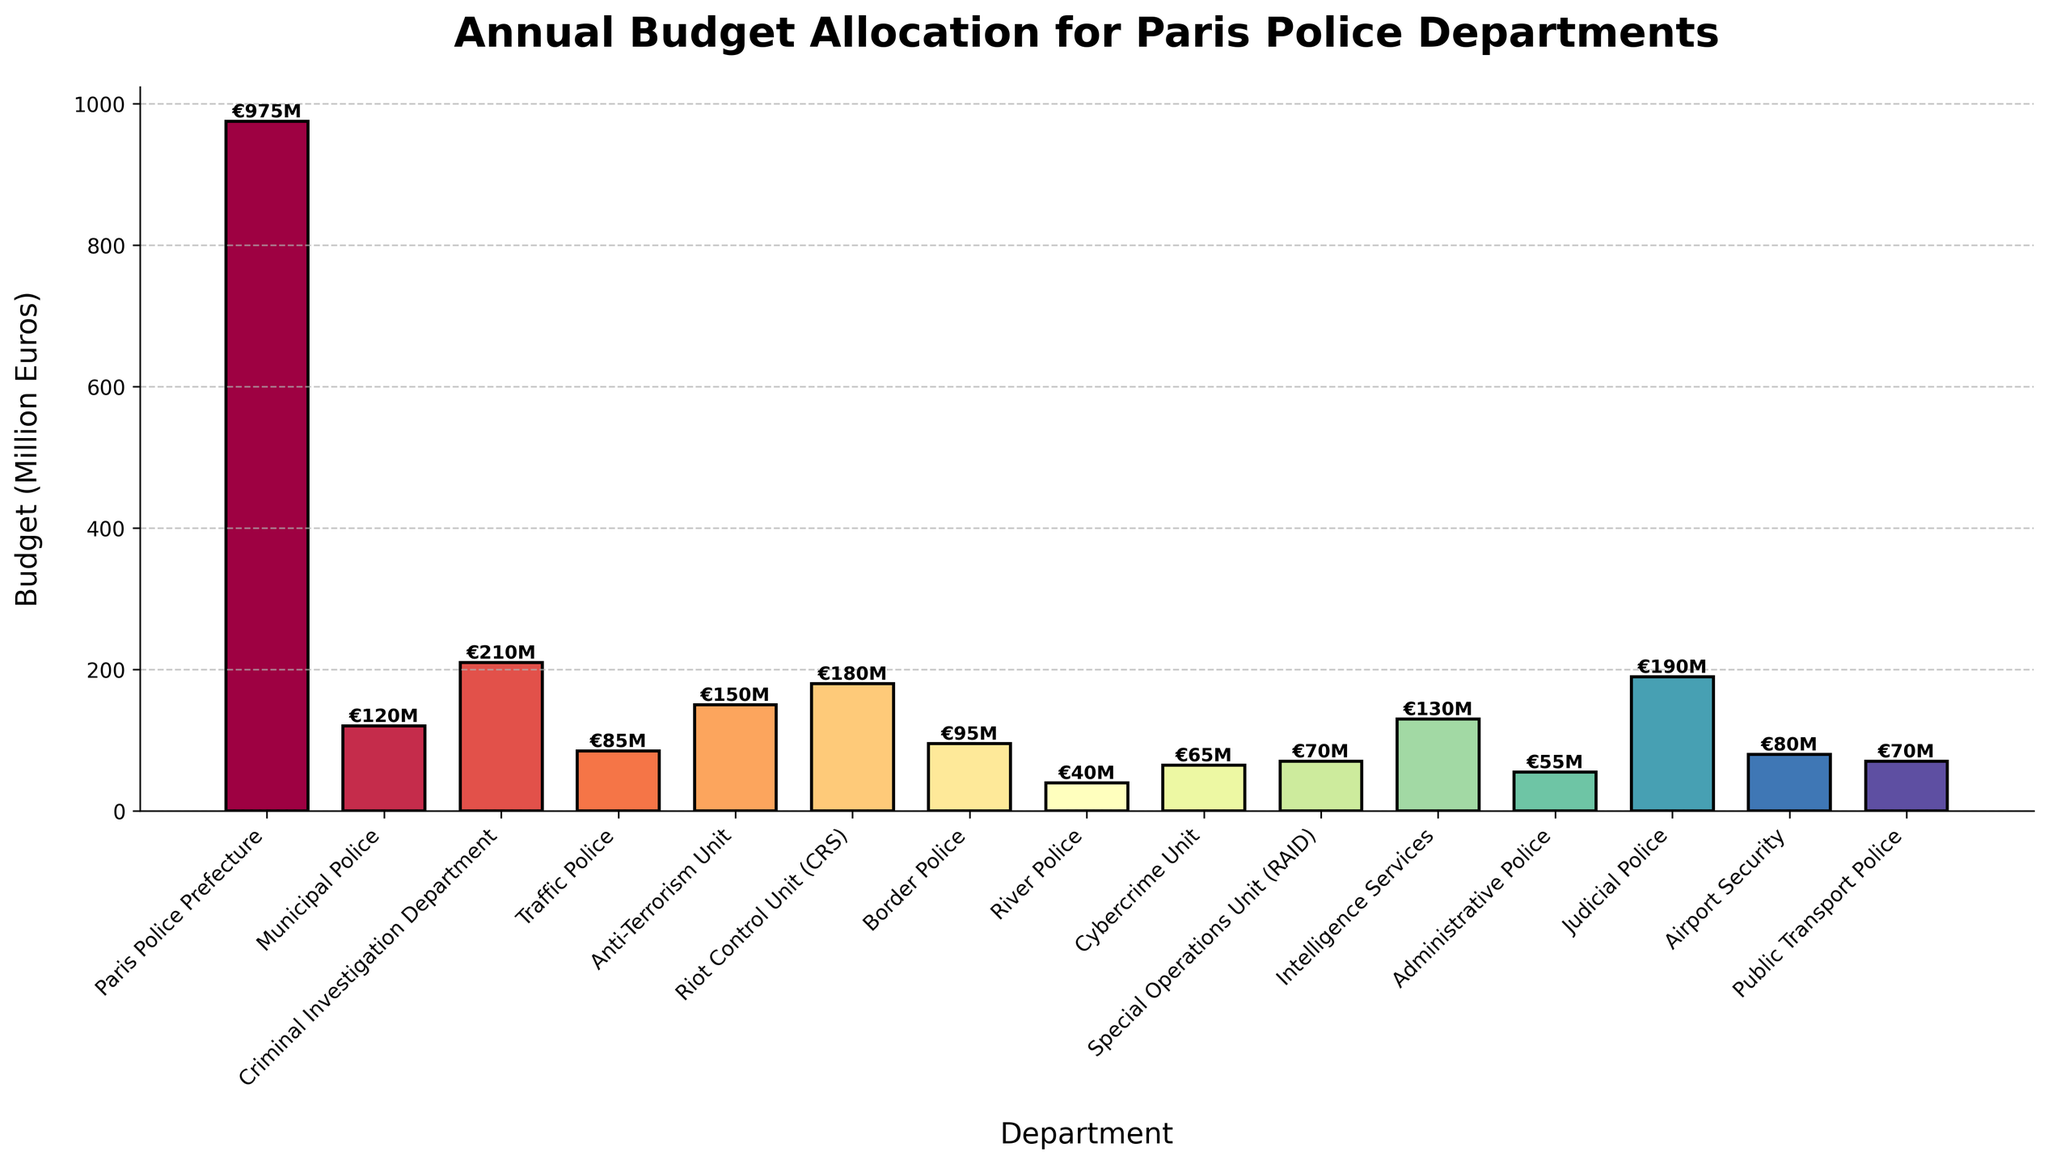Which department has the highest annual budget allocation? The bar with the highest height indicates the department with the highest budget. The Paris Police Prefecture has the highest bar with a budget of 975 million euros.
Answer: Paris Police Prefecture Which department has the lowest annual budget allocation? The bar with the lowest height indicates the department with the lowest budget. The River Police has the lowest bar with a budget of 40 million euros.
Answer: River Police What is the average budget allocation for all departments? To find the average budget allocation, sum up the budget values of all departments and divide by the number of departments. The total budget is 2,515 million euros (975 + 120 + 210 + 85 + 150 + 180 + 95 + 40 + 65 + 70 + 130 + 55 + 190 + 80 + 70), and there are 15 departments, so the average is 2,515 / 15 ≈ 167.67 million euros.
Answer: 167.67 million euros How much more is the budget for the Criminal Investigation Department compared to the Cybercrime Unit? Subtract the budget of the Cybercrime Unit from the budget of the Criminal Investigation Department. The Criminal Investigation Department has 210 million euros and the Cybercrime Unit has 65 million euros. Therefore, 210 - 65 = 145 million euros more.
Answer: 145 million euros Which departments have a budget allocation of at least 150 million euros but not exceeding 200 million euros? Identify the departments whose budgets fall within the specified range. The Anti-Terrorism Unit (150 million euros), Riot Control Unit (180 million euros), and Criminal Investigation Department (210 million euros, excluded as it exceeds 200 million euros). Hence, Anti-Terrorism Unit and Riot Control Unit meet the criteria.
Answer: Anti-Terrorism Unit, Riot Control Unit What is the combined budget of the Public Transport Police, Airport Security, and Special Operations Unit (RAID)? Sum the individual budgets of these departments. The Public Transport Police has 70 million euros, Airport Security has 80 million euros, and RAID has 70 million euros. Therefore, 70 + 80 + 70 = 220 million euros.
Answer: 220 million euros Which department has a budget closest to the average budget allocation of all departments? Calculate the average budget allocation (167.67 million euros). Compare each department's budget to see which is closest. The Intelligence Services have the closest budget of 130 million euros.
Answer: Intelligence Services Are there any departments with the same budget allocation? Identify departments that have identical budget values. The Public Transport Police and Special Operations Unit (RAID) both have 70 million euros.
Answer: Yes, Public Transport Police and Special Operations Unit (RAID) Which color represents the Traffic Police in the chart? Inspect the bar corresponding to the Traffic Police department. The specific color can be identified by looking at the bar visually. For this question, assume the colors are not explicitly listed.
Answer: [Visual inspection required] How much less is the budget of the Administrative Police compared to the Municipal Police? Subtract the budget of the Administrative Police from that of the Municipal Police. The Municipal Police have 120 million euros and the Administrative Police have 55 million euros. Therefore, 120 - 55 = 65 million euros less.
Answer: 65 million euros 